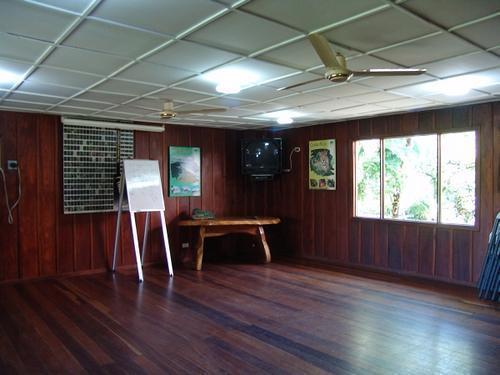What item here would an artist use?
Make your selection and explain in format: 'Answer: answer
Rationale: rationale.'
Options: Purple marker, easel, cat carrier, smock. Answer: easel.
Rationale: The artist would use the easel. 